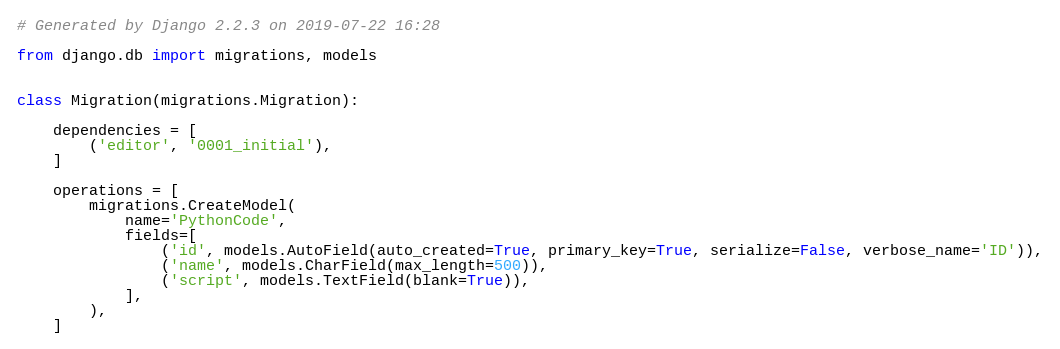Convert code to text. <code><loc_0><loc_0><loc_500><loc_500><_Python_># Generated by Django 2.2.3 on 2019-07-22 16:28

from django.db import migrations, models


class Migration(migrations.Migration):

    dependencies = [
        ('editor', '0001_initial'),
    ]

    operations = [
        migrations.CreateModel(
            name='PythonCode',
            fields=[
                ('id', models.AutoField(auto_created=True, primary_key=True, serialize=False, verbose_name='ID')),
                ('name', models.CharField(max_length=500)),
                ('script', models.TextField(blank=True)),
            ],
        ),
    ]
</code> 